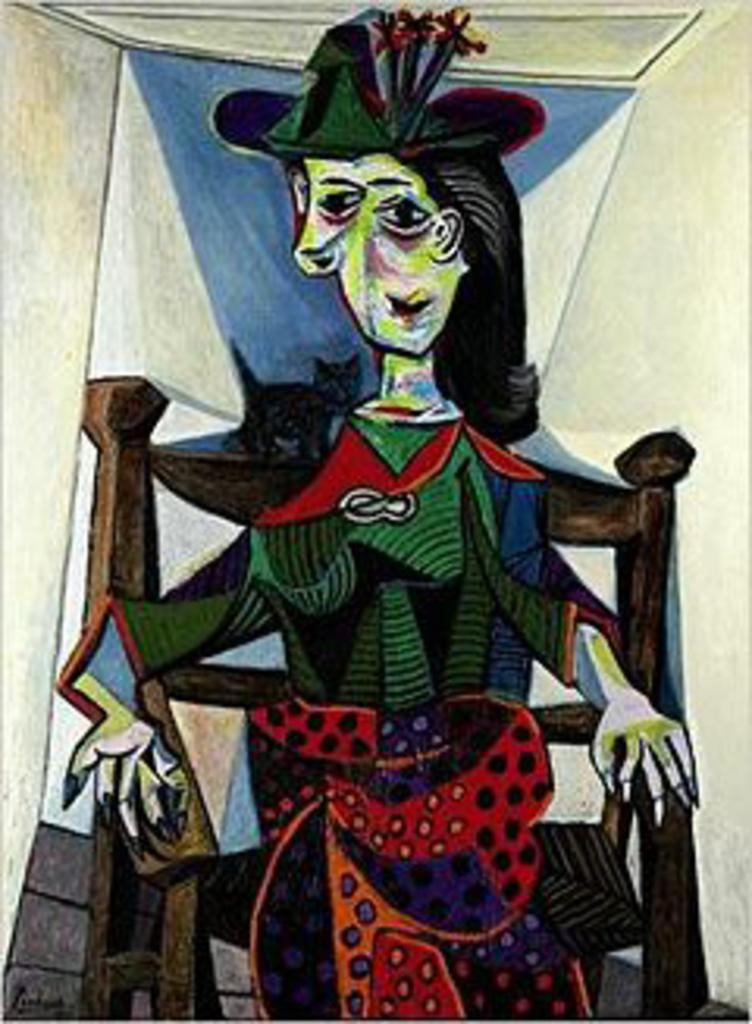What is the main subject of the image? There is a painting in the image. What is the painting depicting? The painting depicts a person sitting on a chair. How many cherries are on the person's plate in the painting? There is no plate or cherries present in the painting; it only depicts a person sitting on a chair. What event is being celebrated in the painting? There is no event being celebrated in the painting; it simply shows a person sitting on a chair. 